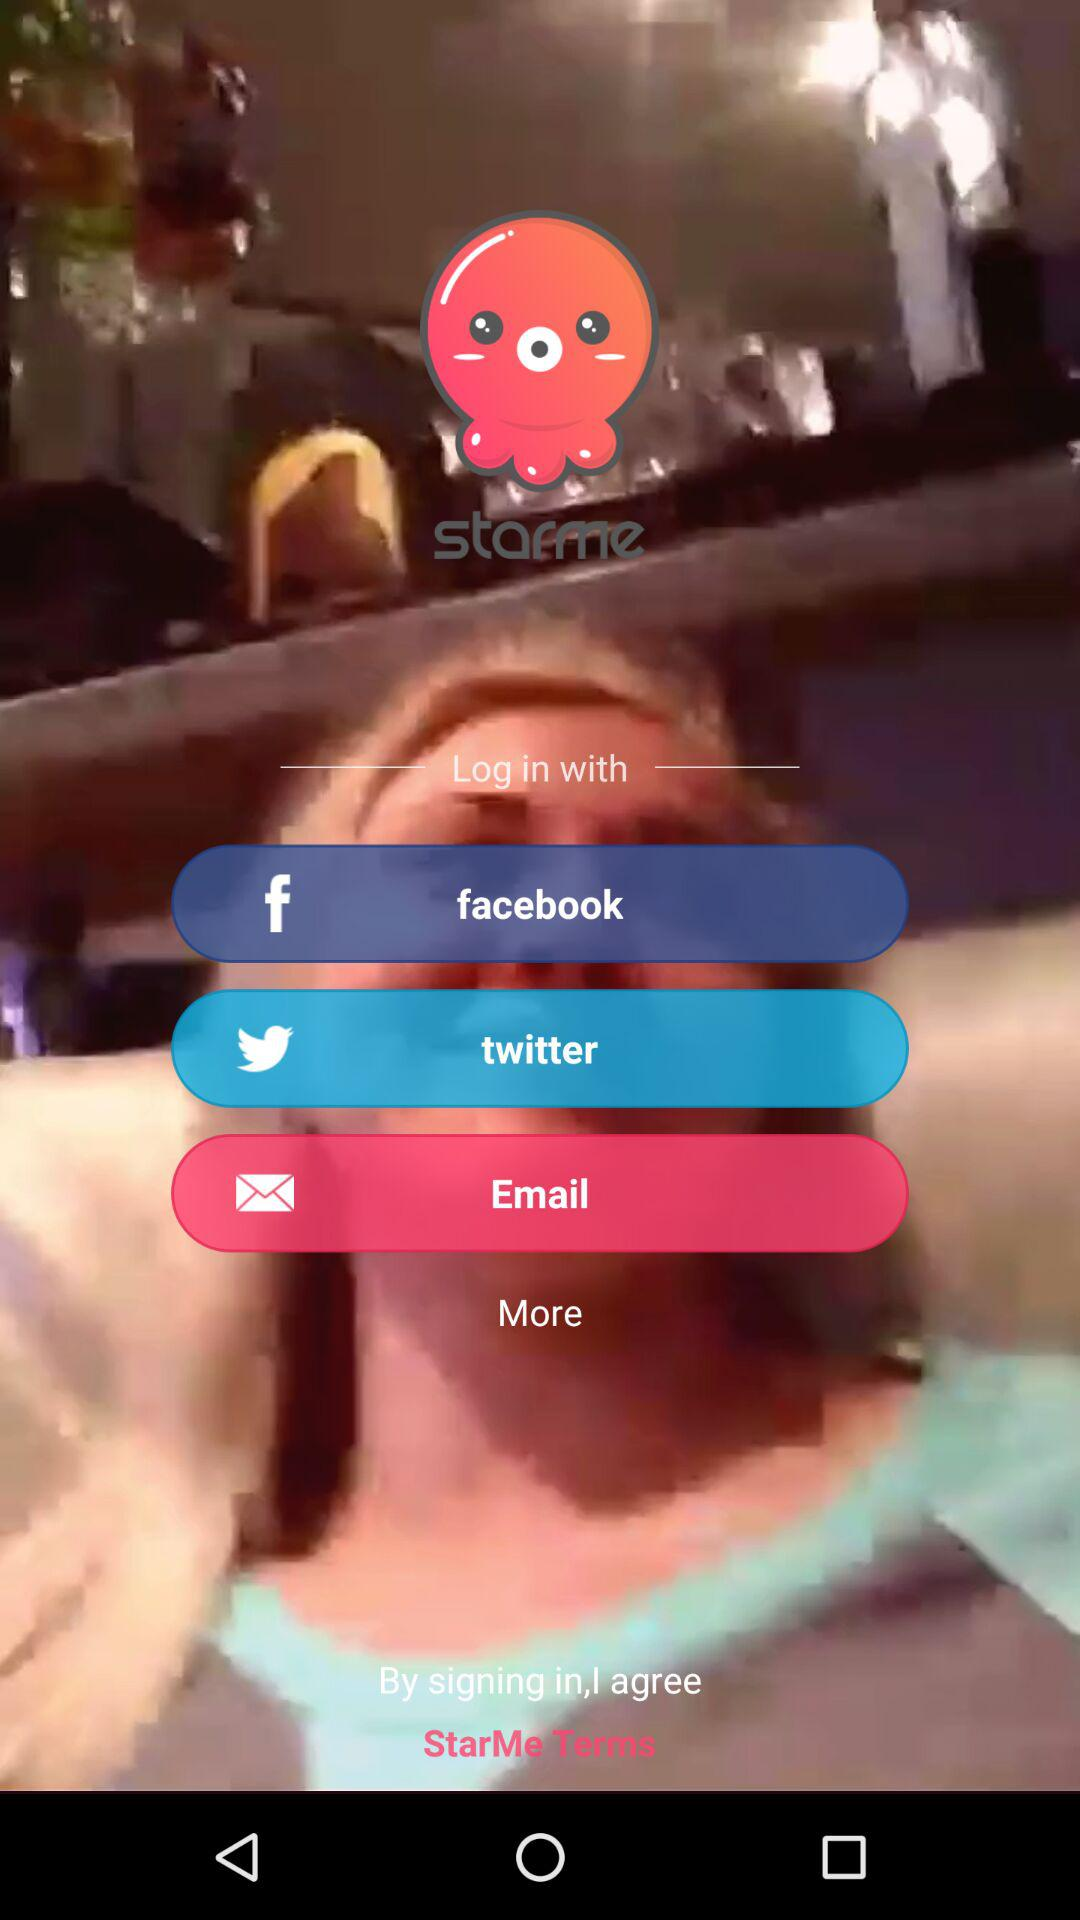Which applications can we use to log in with? You can log in with "facebook" and "twitter". 